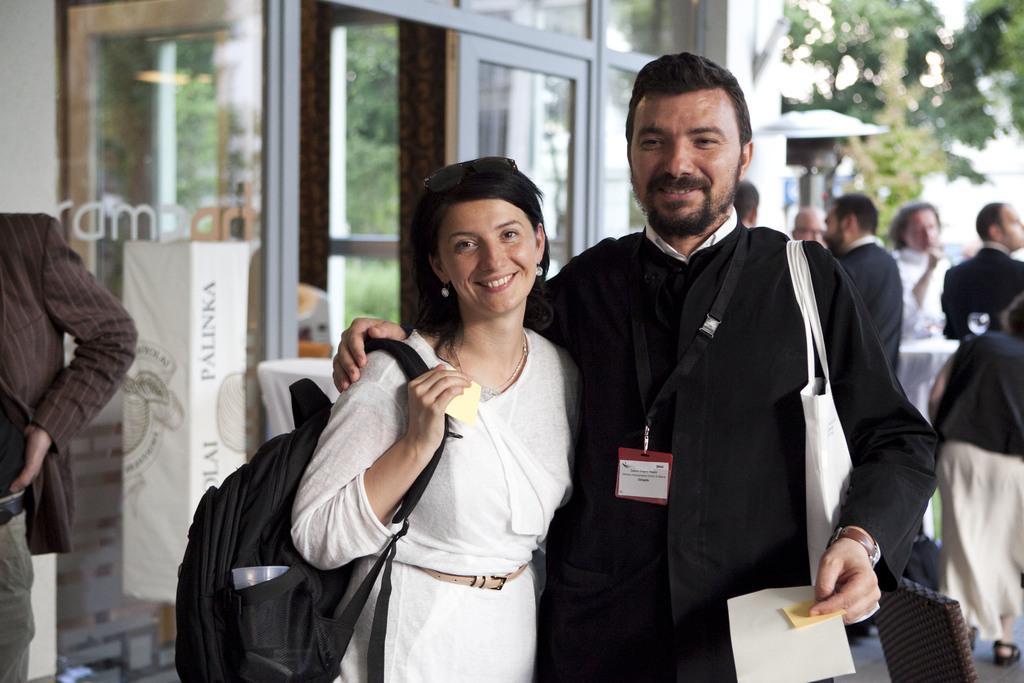How would you summarize this image in a sentence or two? In this image we can see a lady wearing backpack and a guy who is holding something and around there are some other people, tree and the glass door. 